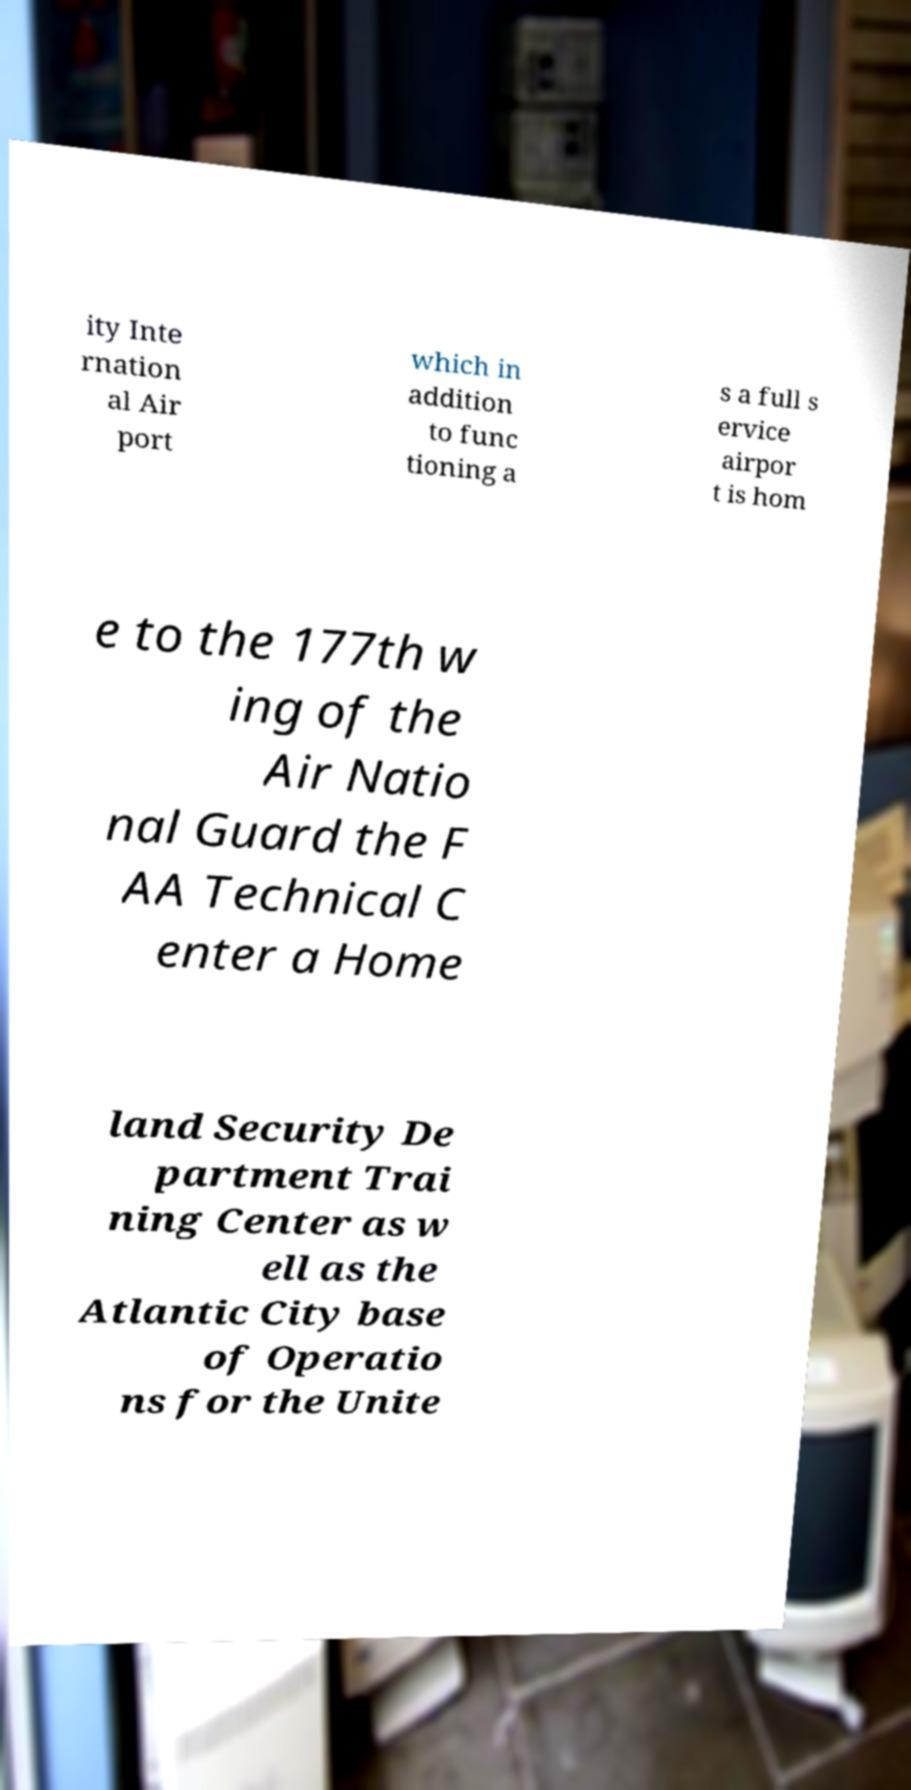What messages or text are displayed in this image? I need them in a readable, typed format. ity Inte rnation al Air port which in addition to func tioning a s a full s ervice airpor t is hom e to the 177th w ing of the Air Natio nal Guard the F AA Technical C enter a Home land Security De partment Trai ning Center as w ell as the Atlantic City base of Operatio ns for the Unite 